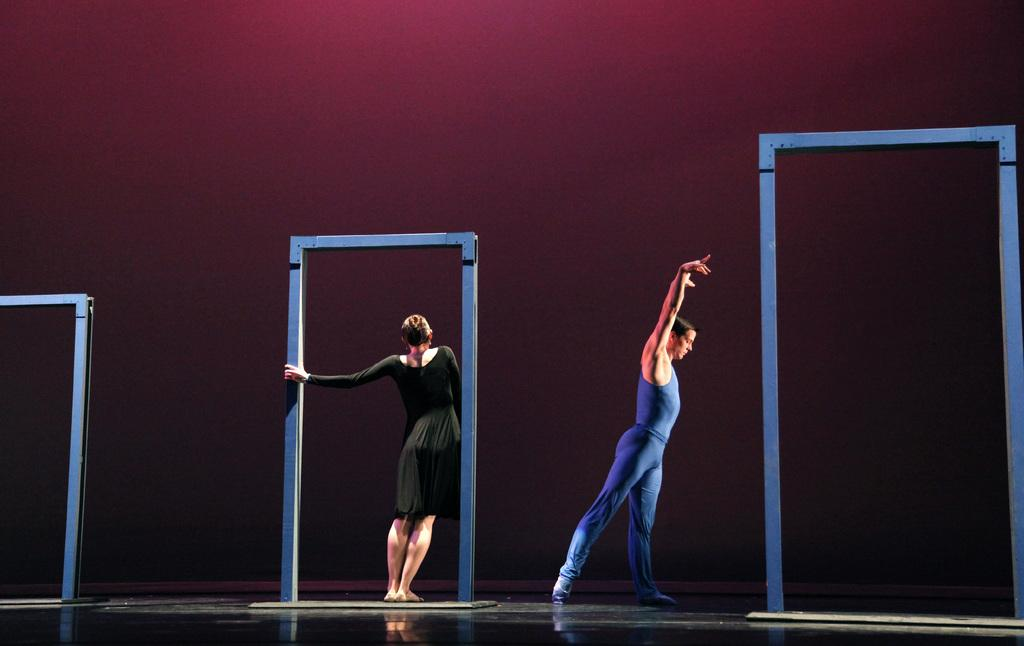What are the two people in the image doing? The two people in the image are dancing. What else can be seen in the image besides the dancing people? There are other objects visible in the image. What is in the background of the image? There is a wall in the background of the image. Can you see a banana floating down the river in the image? There is no banana or river present in the image. What type of soup is being served at the event in the image? There is no event or soup present in the image. 